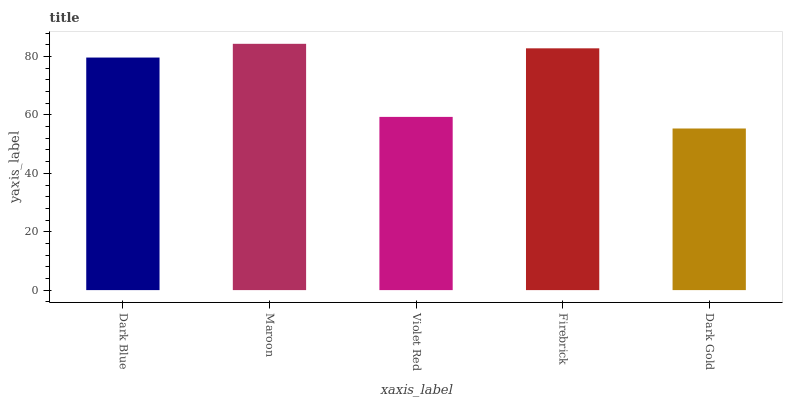Is Dark Gold the minimum?
Answer yes or no. Yes. Is Maroon the maximum?
Answer yes or no. Yes. Is Violet Red the minimum?
Answer yes or no. No. Is Violet Red the maximum?
Answer yes or no. No. Is Maroon greater than Violet Red?
Answer yes or no. Yes. Is Violet Red less than Maroon?
Answer yes or no. Yes. Is Violet Red greater than Maroon?
Answer yes or no. No. Is Maroon less than Violet Red?
Answer yes or no. No. Is Dark Blue the high median?
Answer yes or no. Yes. Is Dark Blue the low median?
Answer yes or no. Yes. Is Dark Gold the high median?
Answer yes or no. No. Is Maroon the low median?
Answer yes or no. No. 